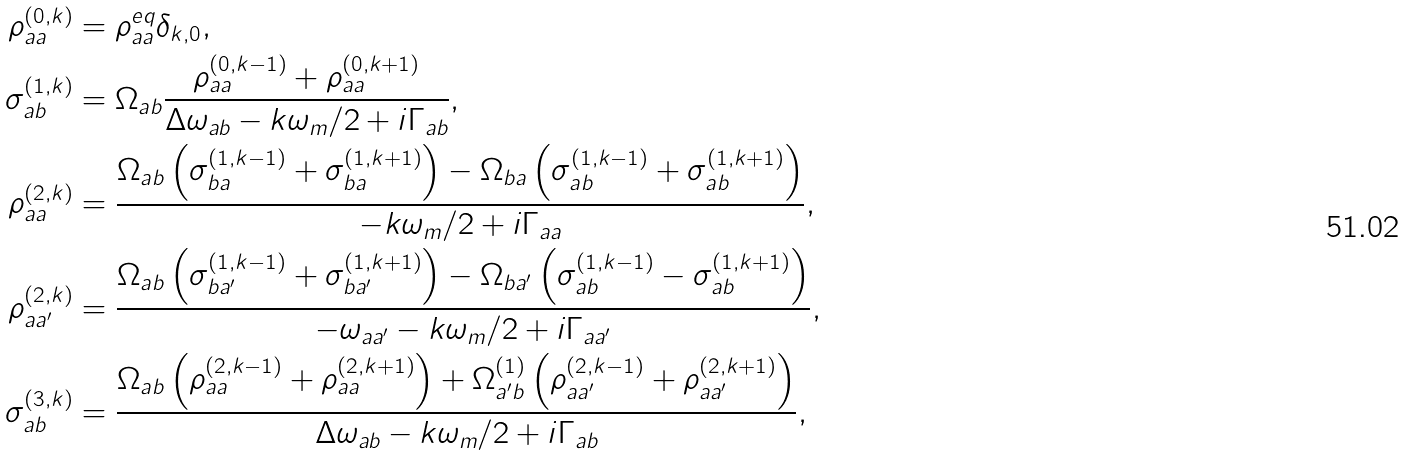Convert formula to latex. <formula><loc_0><loc_0><loc_500><loc_500>\rho ^ { ( 0 , k ) } _ { a a } & = \rho ^ { e q } _ { a a } \delta _ { k , 0 } , \\ \sigma ^ { ( 1 , k ) } _ { a b } & = \Omega _ { a b } \frac { \rho _ { a a } ^ { ( 0 , k - 1 ) } + \rho _ { a a } ^ { ( 0 , k + 1 ) } } { \Delta \omega _ { a b } - k \omega _ { m } / 2 + i \Gamma _ { a b } } , \\ \rho ^ { ( 2 , k ) } _ { a a } & = \frac { \Omega _ { a b } \left ( \sigma ^ { ( 1 , k - 1 ) } _ { b a } + \sigma ^ { ( 1 , k + 1 ) } _ { b a } \right ) - \Omega _ { b a } \left ( \sigma _ { a b } ^ { ( 1 , k - 1 ) } + \sigma _ { a b } ^ { ( 1 , k + 1 ) } \right ) } { - k \omega _ { m } / 2 + i \Gamma _ { a a } } , \\ \rho ^ { ( 2 , k ) } _ { a a ^ { \prime } } & = \frac { \Omega _ { a b } \left ( \sigma ^ { ( 1 , k - 1 ) } _ { b a ^ { \prime } } + \sigma ^ { ( 1 , k + 1 ) } _ { b a ^ { \prime } } \right ) - \Omega _ { b a ^ { \prime } } \left ( \sigma _ { a b } ^ { ( 1 , k - 1 ) } - \sigma _ { a b } ^ { ( 1 , k + 1 ) } \right ) } { - \omega _ { a a ^ { \prime } } - k \omega _ { m } / 2 + i \Gamma _ { a a ^ { \prime } } } , \\ \sigma ^ { ( 3 , k ) } _ { a b } & = \frac { \Omega _ { a b } \left ( \rho _ { a a } ^ { ( 2 , k - 1 ) } + \rho _ { a a } ^ { ( 2 , k + 1 ) } \right ) + \Omega ^ { ( 1 ) } _ { a ^ { \prime } b } \left ( \rho _ { a a ^ { \prime } } ^ { ( 2 , k - 1 ) } + \rho _ { a a ^ { \prime } } ^ { ( 2 , k + 1 ) } \right ) } { \Delta \omega _ { a b } - k \omega _ { m } / 2 + i \Gamma _ { a b } } ,</formula> 